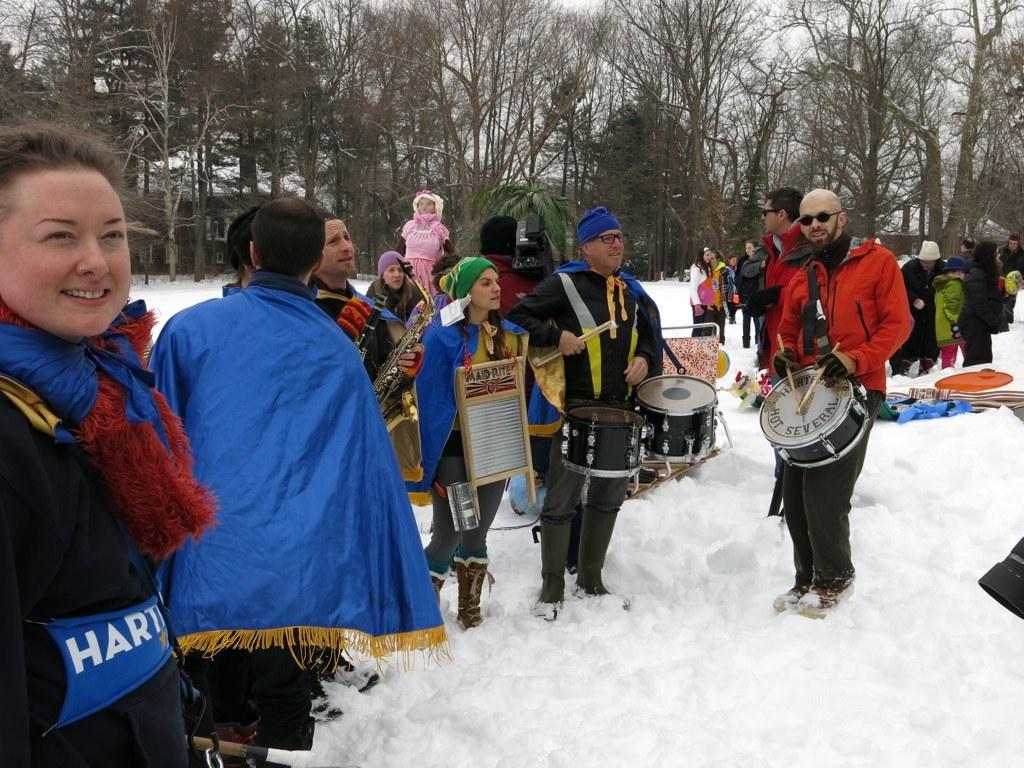Is this a band?
Your answer should be very brief. Answering does not require reading text in the image. What does it say on the top of the woman on the left?
Make the answer very short. Hart. 